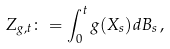<formula> <loc_0><loc_0><loc_500><loc_500>Z _ { g , t } \colon = \int _ { 0 } ^ { t } g ( X _ { s } ) d B _ { s } \, ,</formula> 